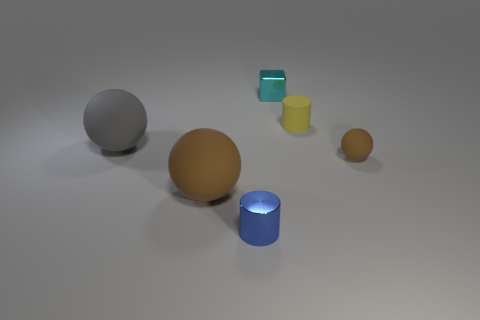Is the number of tiny rubber objects that are left of the gray ball less than the number of gray matte balls?
Ensure brevity in your answer.  Yes. How many tiny shiny blocks are the same color as the tiny matte sphere?
Your answer should be very brief. 0. What material is the tiny thing that is both to the left of the tiny yellow matte cylinder and in front of the small cyan metal object?
Make the answer very short. Metal. There is a sphere that is right of the big brown matte object; is it the same color as the large object that is in front of the gray rubber object?
Make the answer very short. Yes. How many brown objects are shiny blocks or small matte spheres?
Your response must be concise. 1. Are there fewer large brown rubber things to the right of the cyan metallic thing than rubber things that are behind the tiny blue cylinder?
Your answer should be compact. Yes. Is there a rubber cylinder of the same size as the yellow rubber object?
Make the answer very short. No. There is a brown ball that is on the right side of the blue object; does it have the same size as the tiny cyan metallic block?
Give a very brief answer. Yes. Are there more yellow cylinders than big red shiny cylinders?
Keep it short and to the point. Yes. Are there any other matte things that have the same shape as the small blue object?
Your answer should be compact. Yes. 